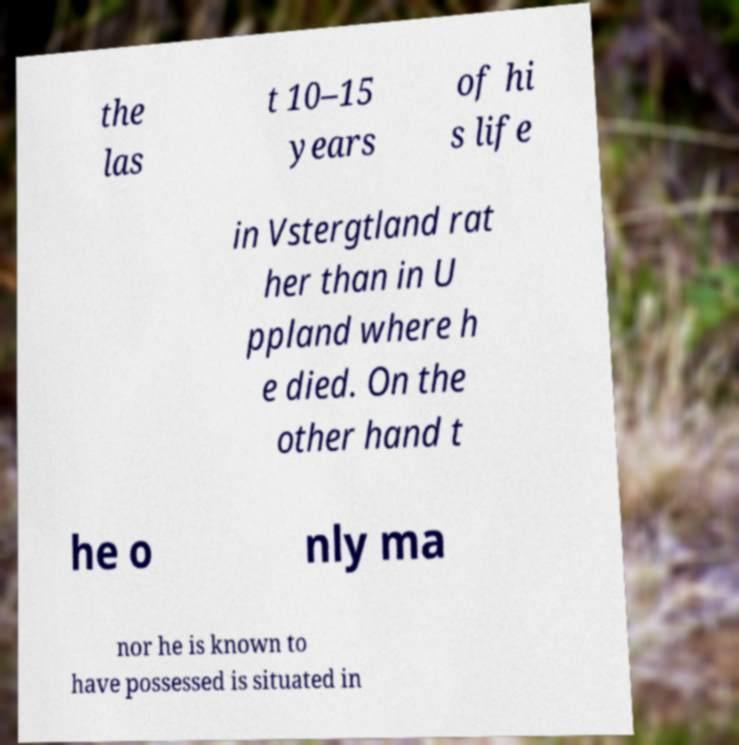Please read and relay the text visible in this image. What does it say? the las t 10–15 years of hi s life in Vstergtland rat her than in U ppland where h e died. On the other hand t he o nly ma nor he is known to have possessed is situated in 